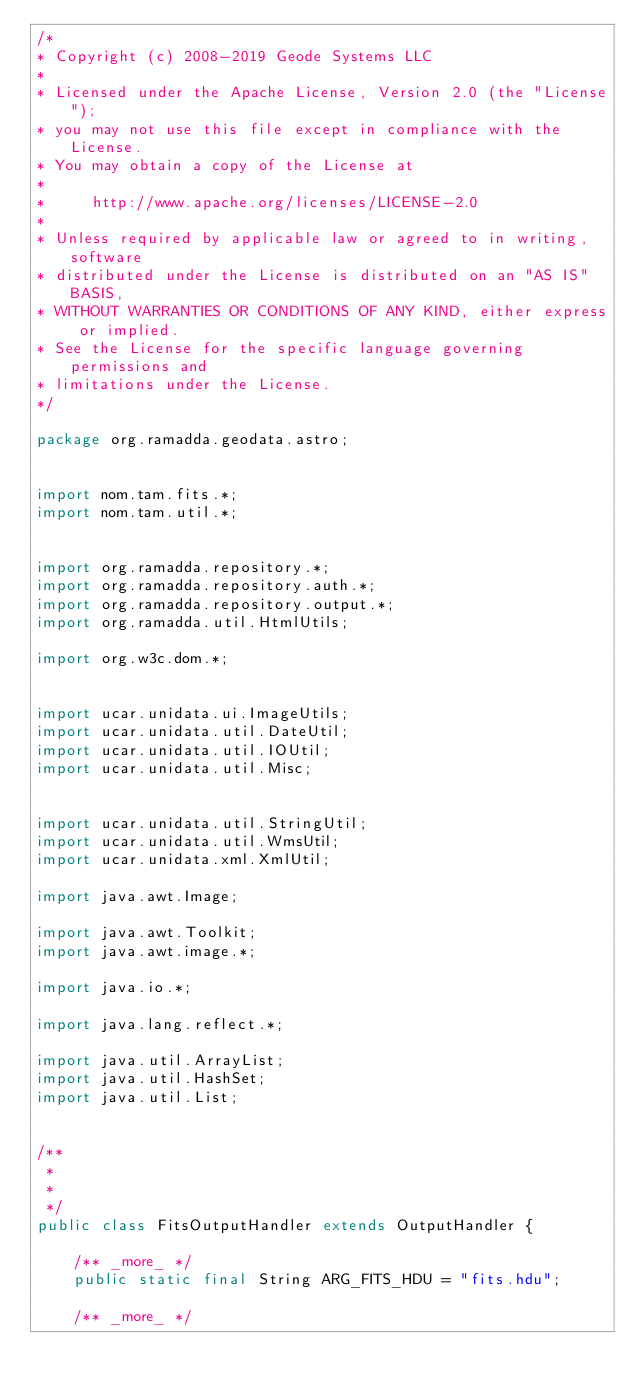Convert code to text. <code><loc_0><loc_0><loc_500><loc_500><_Java_>/*
* Copyright (c) 2008-2019 Geode Systems LLC
*
* Licensed under the Apache License, Version 2.0 (the "License");
* you may not use this file except in compliance with the License.
* You may obtain a copy of the License at
* 
*     http://www.apache.org/licenses/LICENSE-2.0
* 
* Unless required by applicable law or agreed to in writing, software
* distributed under the License is distributed on an "AS IS" BASIS,
* WITHOUT WARRANTIES OR CONDITIONS OF ANY KIND, either express or implied.
* See the License for the specific language governing permissions and
* limitations under the License.
*/

package org.ramadda.geodata.astro;


import nom.tam.fits.*;
import nom.tam.util.*;


import org.ramadda.repository.*;
import org.ramadda.repository.auth.*;
import org.ramadda.repository.output.*;
import org.ramadda.util.HtmlUtils;

import org.w3c.dom.*;


import ucar.unidata.ui.ImageUtils;
import ucar.unidata.util.DateUtil;
import ucar.unidata.util.IOUtil;
import ucar.unidata.util.Misc;


import ucar.unidata.util.StringUtil;
import ucar.unidata.util.WmsUtil;
import ucar.unidata.xml.XmlUtil;

import java.awt.Image;

import java.awt.Toolkit;
import java.awt.image.*;

import java.io.*;

import java.lang.reflect.*;

import java.util.ArrayList;
import java.util.HashSet;
import java.util.List;


/**
 *
 *
 */
public class FitsOutputHandler extends OutputHandler {

    /** _more_ */
    public static final String ARG_FITS_HDU = "fits.hdu";

    /** _more_ */</code> 